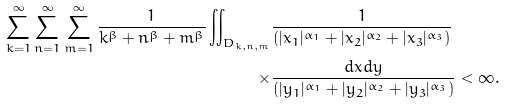Convert formula to latex. <formula><loc_0><loc_0><loc_500><loc_500>\sum _ { k = 1 } ^ { \infty } \sum _ { n = 1 } ^ { \infty } \sum _ { m = 1 } ^ { \infty } \frac { 1 } { k ^ { \beta } + n ^ { \beta } + m ^ { \beta } } \iint _ { D _ { k , n , m } } & \frac { 1 } { ( | x _ { 1 } | ^ { \alpha _ { 1 } } + | x _ { 2 } | ^ { \alpha _ { 2 } } + | x _ { 3 } | ^ { \alpha _ { 3 } } ) } \\ \times & \frac { d x d y } { ( | y _ { 1 } | ^ { \alpha _ { 1 } } + | y _ { 2 } | ^ { \alpha _ { 2 } } + | y _ { 3 } | ^ { \alpha _ { 3 } } ) } < \infty .</formula> 